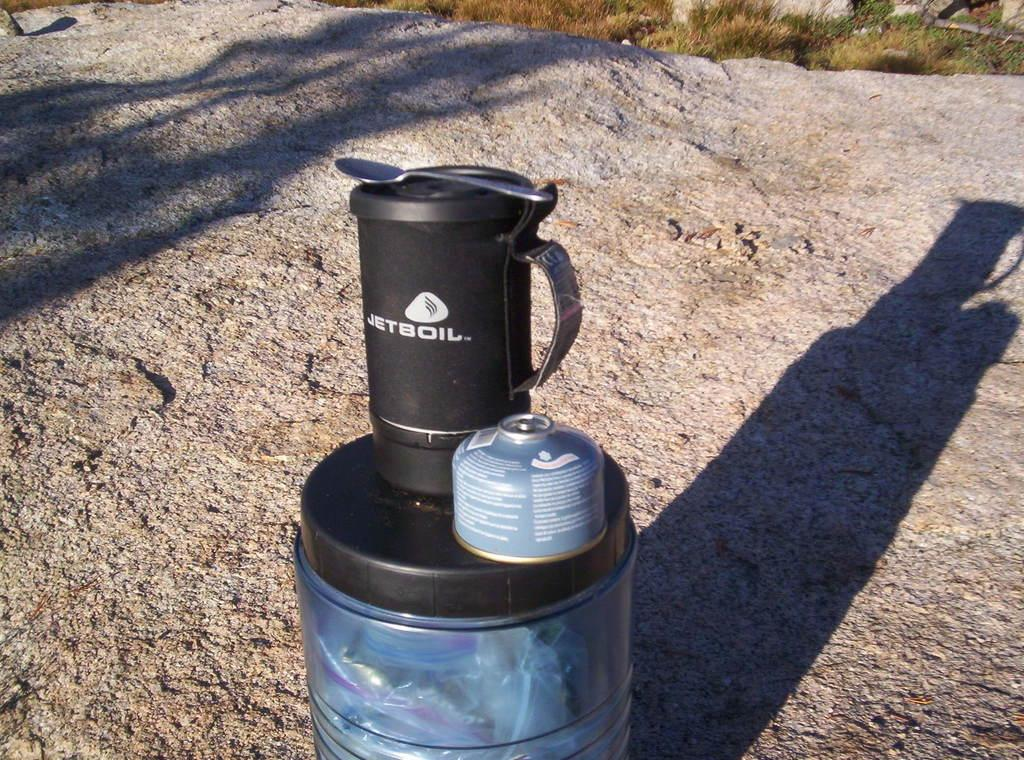<image>
Give a short and clear explanation of the subsequent image. The utensil here with a spoon sitting on it is called Jetboil. 